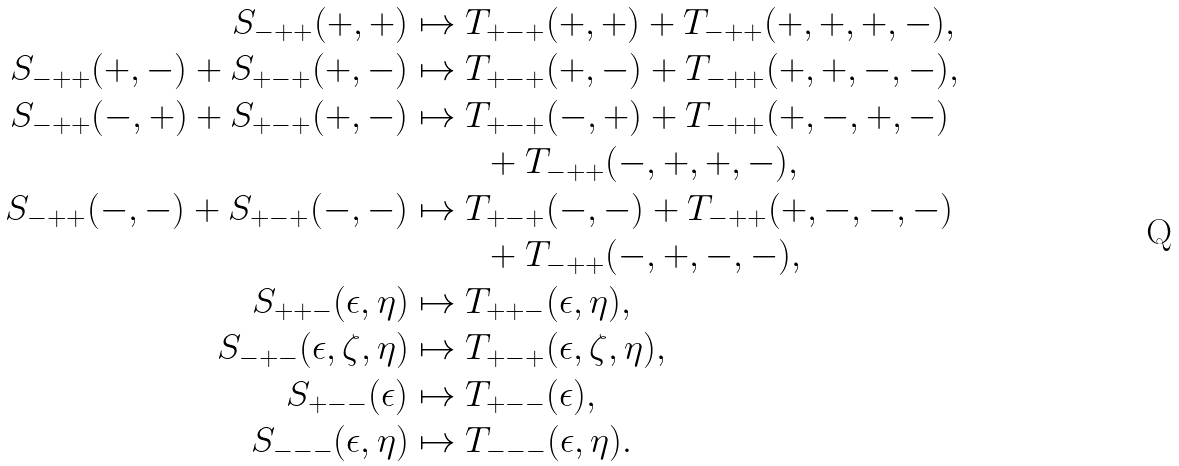<formula> <loc_0><loc_0><loc_500><loc_500>S _ { - + + } ( + , + ) & \mapsto T _ { + - + } ( + , + ) + T _ { - + + } ( + , + , + , - ) , \\ S _ { - + + } ( + , - ) + S _ { + - + } ( + , - ) & \mapsto T _ { + - + } ( + , - ) + T _ { - + + } ( + , + , - , - ) , \\ S _ { - + + } ( - , + ) + S _ { + - + } ( + , - ) & \mapsto T _ { + - + } ( - , + ) + T _ { - + + } ( + , - , + , - ) \\ & \quad \, \quad + T _ { - + + } ( - , + , + , - ) , \\ S _ { - + + } ( - , - ) + S _ { + - + } ( - , - ) & \mapsto T _ { + - + } ( - , - ) + T _ { - + + } ( + , - , - , - ) \\ & \quad \, \quad + T _ { - + + } ( - , + , - , - ) , \\ S _ { + + - } ( \epsilon , \eta ) & \mapsto T _ { + + - } ( \epsilon , \eta ) , \\ S _ { - + - } ( \epsilon , \zeta , \eta ) & \mapsto T _ { + - + } ( \epsilon , \zeta , \eta ) , \\ S _ { + - - } ( \epsilon ) & \mapsto T _ { + - - } ( \epsilon ) , \\ S _ { - - - } ( \epsilon , \eta ) & \mapsto T _ { - - - } ( \epsilon , \eta ) .</formula> 